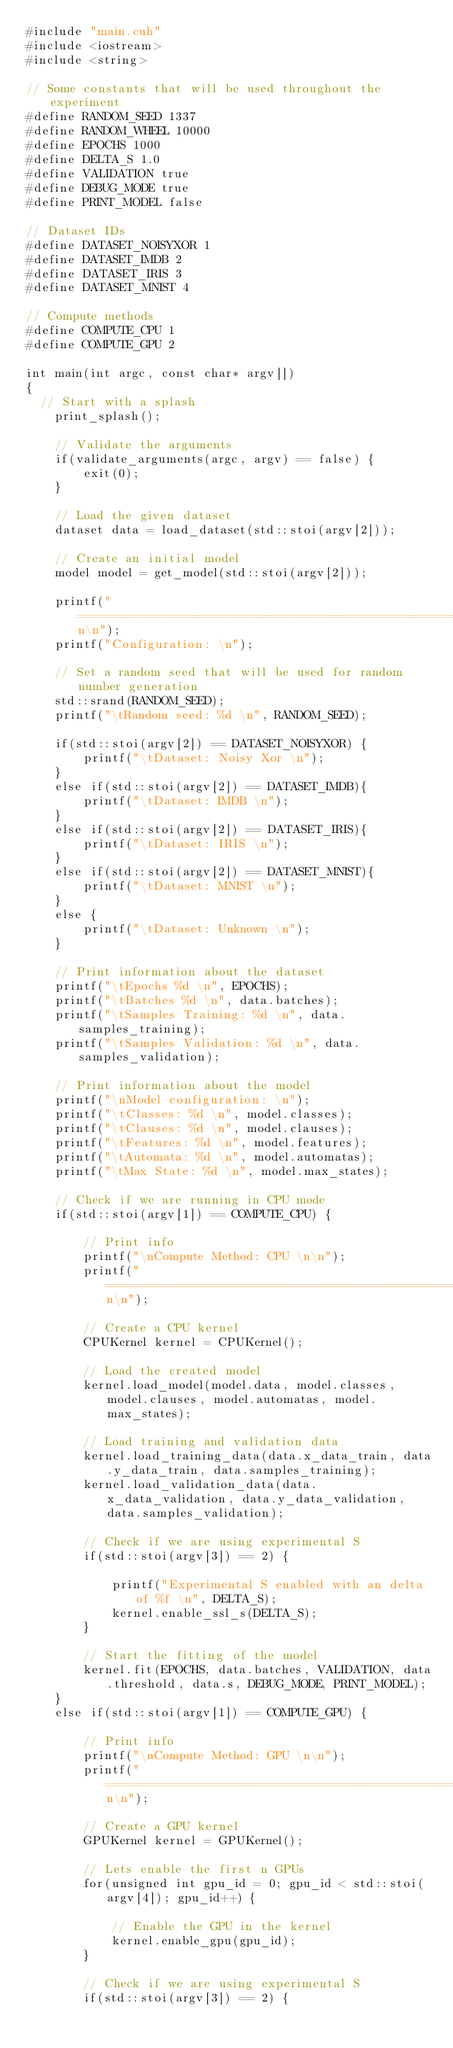<code> <loc_0><loc_0><loc_500><loc_500><_Cuda_>#include "main.cuh"
#include <iostream>
#include <string>

// Some constants that will be used throughout the experiment
#define RANDOM_SEED 1337
#define RANDOM_WHEEL 10000
#define EPOCHS 1000
#define DELTA_S 1.0
#define VALIDATION true
#define DEBUG_MODE true
#define PRINT_MODEL false

// Dataset IDs
#define DATASET_NOISYXOR 1
#define DATASET_IMDB 2
#define DATASET_IRIS 3
#define DATASET_MNIST 4

// Compute methods
#define COMPUTE_CPU 1
#define COMPUTE_GPU 2

int main(int argc, const char* argv[])
{
	// Start with a splash
    print_splash();

    // Validate the arguments
    if(validate_arguments(argc, argv) == false) {
        exit(0);
    }

    // Load the given dataset
    dataset data = load_dataset(std::stoi(argv[2]));

    // Create an initial model
    model model = get_model(std::stoi(argv[2]));

    printf("===============================================================\n\n");
    printf("Configuration: \n");

    // Set a random seed that will be used for random number generation
    std::srand(RANDOM_SEED);
    printf("\tRandom seed: %d \n", RANDOM_SEED);

    if(std::stoi(argv[2]) == DATASET_NOISYXOR) {
        printf("\tDataset: Noisy Xor \n");
    }
    else if(std::stoi(argv[2]) == DATASET_IMDB){
        printf("\tDataset: IMDB \n");
    }
    else if(std::stoi(argv[2]) == DATASET_IRIS){
        printf("\tDataset: IRIS \n");
    }
    else if(std::stoi(argv[2]) == DATASET_MNIST){
        printf("\tDataset: MNIST \n");
    }
    else {
        printf("\tDataset: Unknown \n");
    }

    // Print information about the dataset
    printf("\tEpochs %d \n", EPOCHS);
    printf("\tBatches %d \n", data.batches);
    printf("\tSamples Training: %d \n", data.samples_training);
    printf("\tSamples Validation: %d \n", data.samples_validation);

    // Print information about the model
    printf("\nModel configuration: \n");
    printf("\tClasses: %d \n", model.classes);
    printf("\tClauses: %d \n", model.clauses);
    printf("\tFeatures: %d \n", model.features);
    printf("\tAutomata: %d \n", model.automatas);
    printf("\tMax State: %d \n", model.max_states);

    // Check if we are running in CPU mode
    if(std::stoi(argv[1]) == COMPUTE_CPU) {

        // Print info
        printf("\nCompute Method: CPU \n\n");
        printf("===============================================================\n\n");

        // Create a CPU kernel
        CPUKernel kernel = CPUKernel();

        // Load the created model
        kernel.load_model(model.data, model.classes, model.clauses, model.automatas, model.max_states);

        // Load training and validation data
        kernel.load_training_data(data.x_data_train, data.y_data_train, data.samples_training);
        kernel.load_validation_data(data.x_data_validation, data.y_data_validation, data.samples_validation);

        // Check if we are using experimental S
        if(std::stoi(argv[3]) == 2) {
            
            printf("Experimental S enabled with an delta of %f \n", DELTA_S);
            kernel.enable_ssl_s(DELTA_S);
        }

        // Start the fitting of the model
        kernel.fit(EPOCHS, data.batches, VALIDATION, data.threshold, data.s, DEBUG_MODE, PRINT_MODEL);
    }
    else if(std::stoi(argv[1]) == COMPUTE_GPU) {

        // Print info
        printf("\nCompute Method: GPU \n\n");
        printf("===============================================================\n\n");

        // Create a GPU kernel
        GPUKernel kernel = GPUKernel();

        // Lets enable the first n GPUs
        for(unsigned int gpu_id = 0; gpu_id < std::stoi(argv[4]); gpu_id++) {

            // Enable the GPU in the kernel
            kernel.enable_gpu(gpu_id);
        }

        // Check if we are using experimental S
        if(std::stoi(argv[3]) == 2) {</code> 